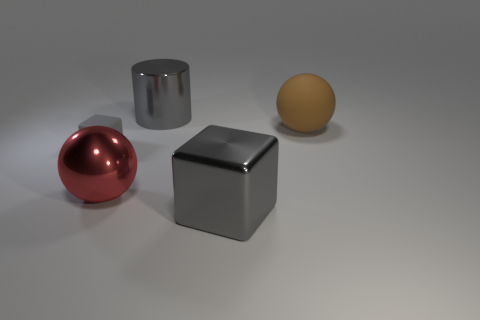Add 1 large yellow balls. How many objects exist? 6 Subtract all spheres. How many objects are left? 3 Subtract all tiny rubber cubes. Subtract all big gray shiny cylinders. How many objects are left? 3 Add 1 tiny gray rubber things. How many tiny gray rubber things are left? 2 Add 2 tiny cyan matte objects. How many tiny cyan matte objects exist? 2 Subtract 0 purple spheres. How many objects are left? 5 